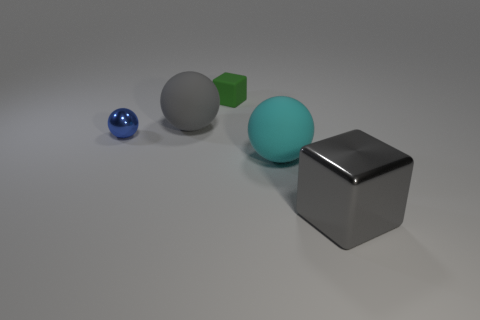Subtract all purple spheres. Subtract all purple cubes. How many spheres are left? 3 Subtract all purple cylinders. How many red blocks are left? 0 Add 5 big reds. How many big grays exist? 0 Subtract all tiny shiny objects. Subtract all big gray metallic blocks. How many objects are left? 3 Add 1 big objects. How many big objects are left? 4 Add 3 green rubber cubes. How many green rubber cubes exist? 4 Add 1 large cyan things. How many objects exist? 6 Subtract all blue balls. How many balls are left? 2 Subtract all large gray spheres. How many spheres are left? 2 Subtract 0 cyan cylinders. How many objects are left? 5 